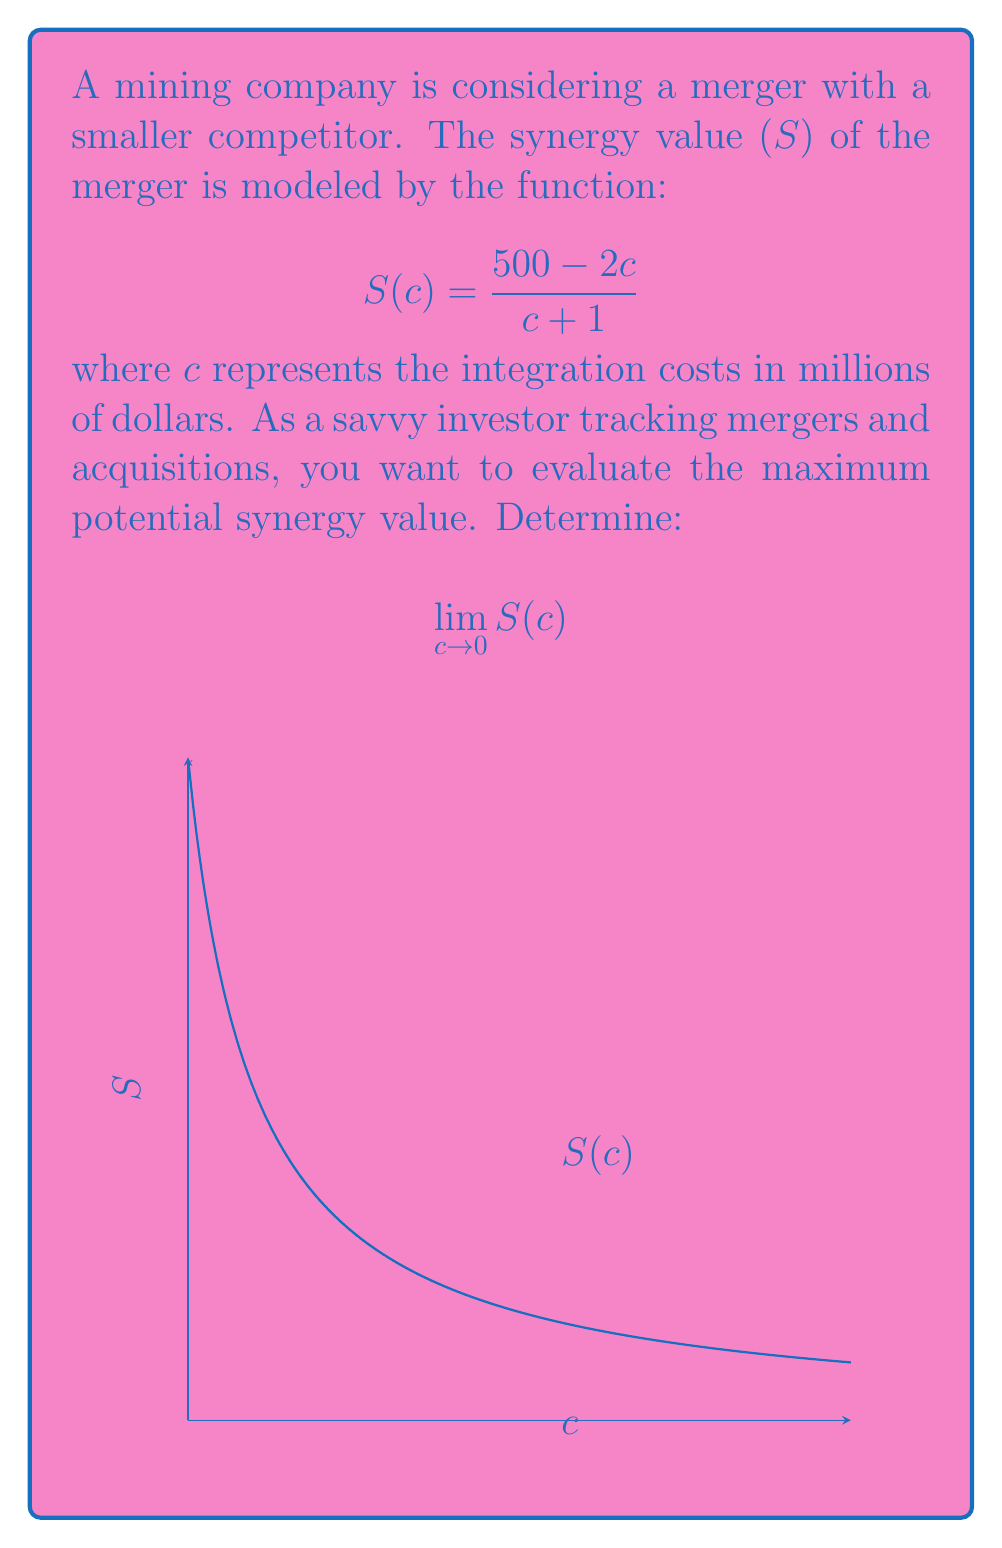Solve this math problem. Let's approach this step-by-step:

1) We're given the function: $$S(c) = \frac{500 - 2c}{c + 1}$$

2) We need to evaluate the limit as c approaches 0:
   $$\lim_{c \to 0} S(c) = \lim_{c \to 0} \frac{500 - 2c}{c + 1}$$

3) We can't directly substitute c = 0, as this would give us 500/1, which isn't the correct limit.

4) Instead, let's manipulate the fraction:
   $$\lim_{c \to 0} \frac{500 - 2c}{c + 1} = \lim_{c \to 0} \frac{500 - 2c}{c + 1} \cdot \frac{1}{1}$$

5) Multiply numerator and denominator by 1/(c+1):
   $$= \lim_{c \to 0} (\frac{500}{c+1} - \frac{2c}{c+1}) \cdot \frac{1}{1}$$

6) This can be rewritten as:
   $$= \lim_{c \to 0} \frac{500}{c+1} - \lim_{c \to 0} \frac{2c}{c+1}$$

7) Now we can evaluate each limit separately:
   $$\lim_{c \to 0} \frac{500}{c+1} = 500$$
   $$\lim_{c \to 0} \frac{2c}{c+1} = 0$$

8) Therefore:
   $$\lim_{c \to 0} S(c) = 500 - 0 = 500$$

This means that as integration costs approach zero, the synergy value approaches 500 million dollars.
Answer: $500$ million dollars 